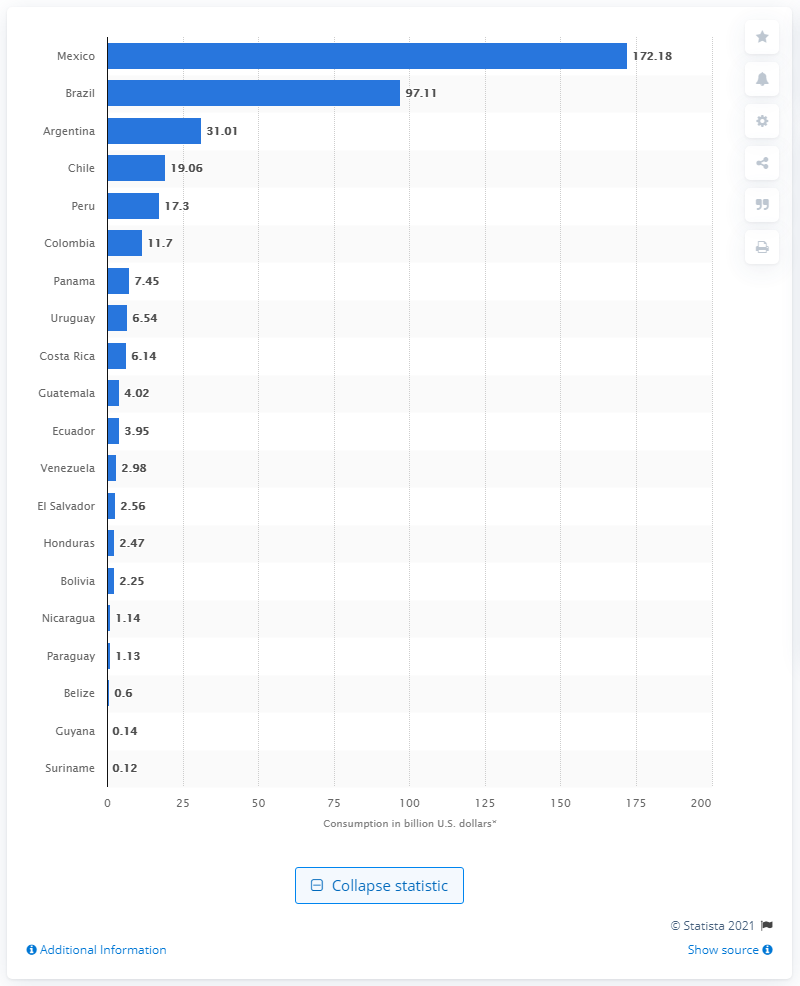Draw attention to some important aspects in this diagram. Brazil was the country with the largest internal consumption of travel and tourism in 2019, according to data. In 2019, Mexico was the country with the largest internal consumption of travel and tourism. 